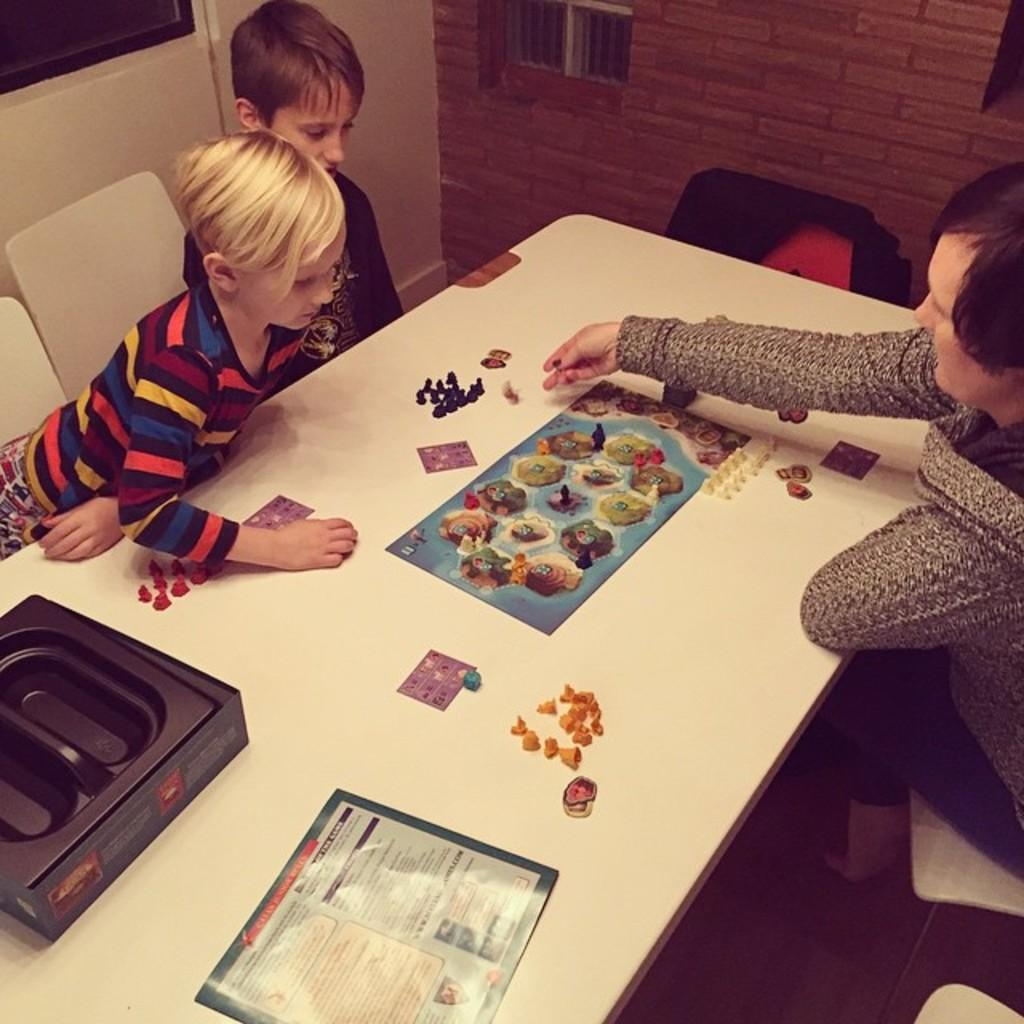Who is present in the image? There is a woman and two children in the image. What objects can be seen on the table in the image? There is a box, a book, and toys on the table in the image. What furniture can be seen in the background of the image? There are chairs in the background of the image. What architectural feature is visible in the background of the image? There is a window and a wall in the background of the image. What type of cable is being used to mine for gold in the image? There is no cable or mining activity present in the image. How many spoons are visible in the image? There is no spoon visible in the image. 